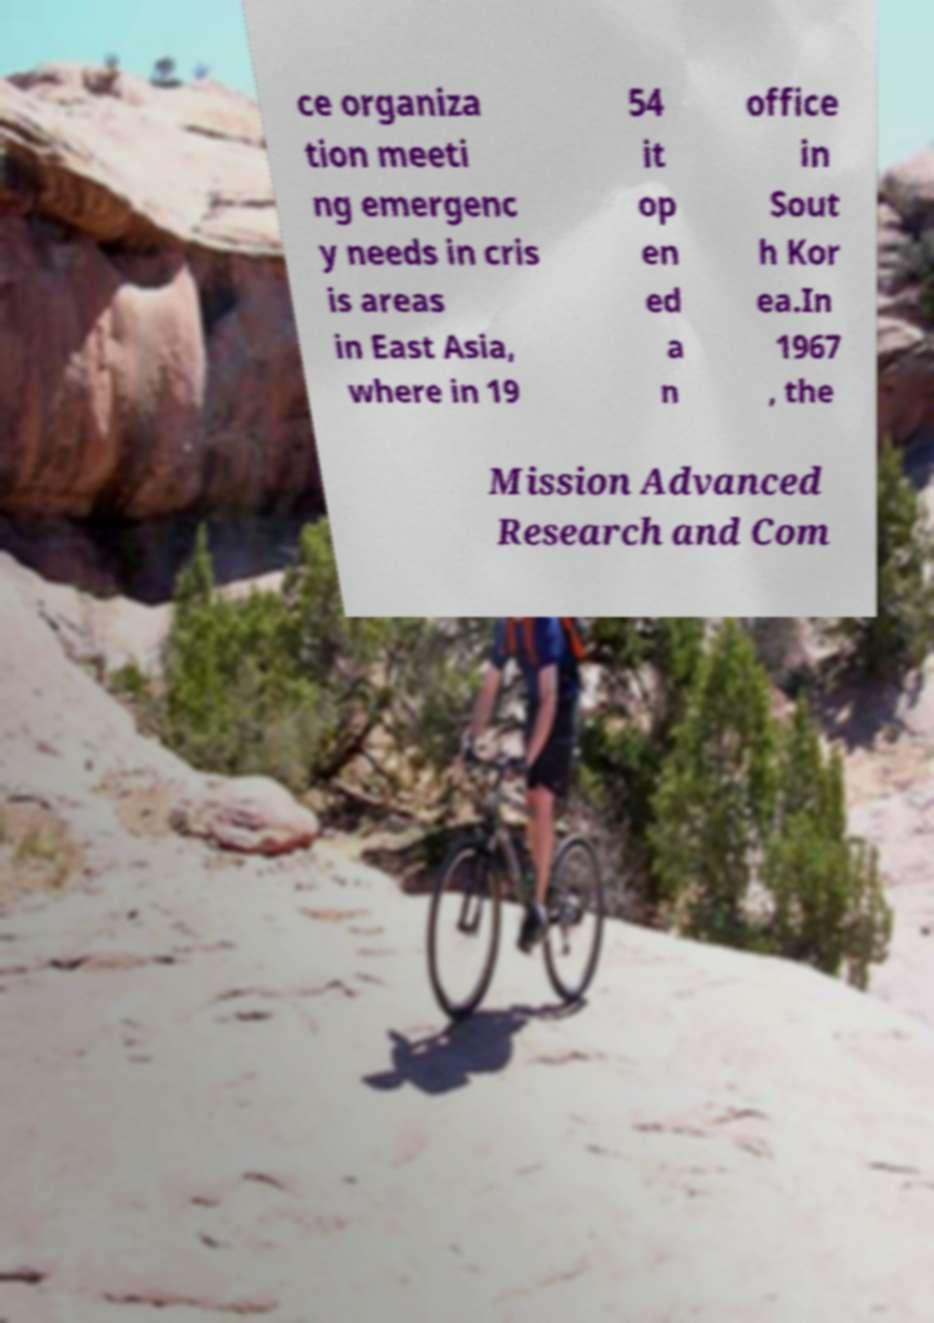Can you read and provide the text displayed in the image?This photo seems to have some interesting text. Can you extract and type it out for me? ce organiza tion meeti ng emergenc y needs in cris is areas in East Asia, where in 19 54 it op en ed a n office in Sout h Kor ea.In 1967 , the Mission Advanced Research and Com 